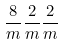Convert formula to latex. <formula><loc_0><loc_0><loc_500><loc_500>\frac { 8 } { m } \frac { 2 } { m } \frac { 2 } { m }</formula> 